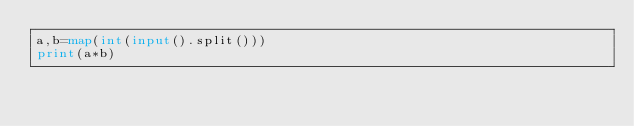<code> <loc_0><loc_0><loc_500><loc_500><_Python_>a,b=map(int(input().split()))
print(a*b)</code> 